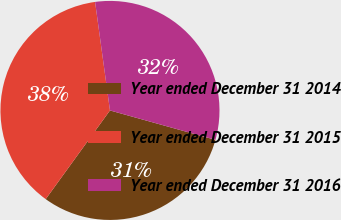Convert chart. <chart><loc_0><loc_0><loc_500><loc_500><pie_chart><fcel>Year ended December 31 2014<fcel>Year ended December 31 2015<fcel>Year ended December 31 2016<nl><fcel>30.65%<fcel>37.85%<fcel>31.5%<nl></chart> 